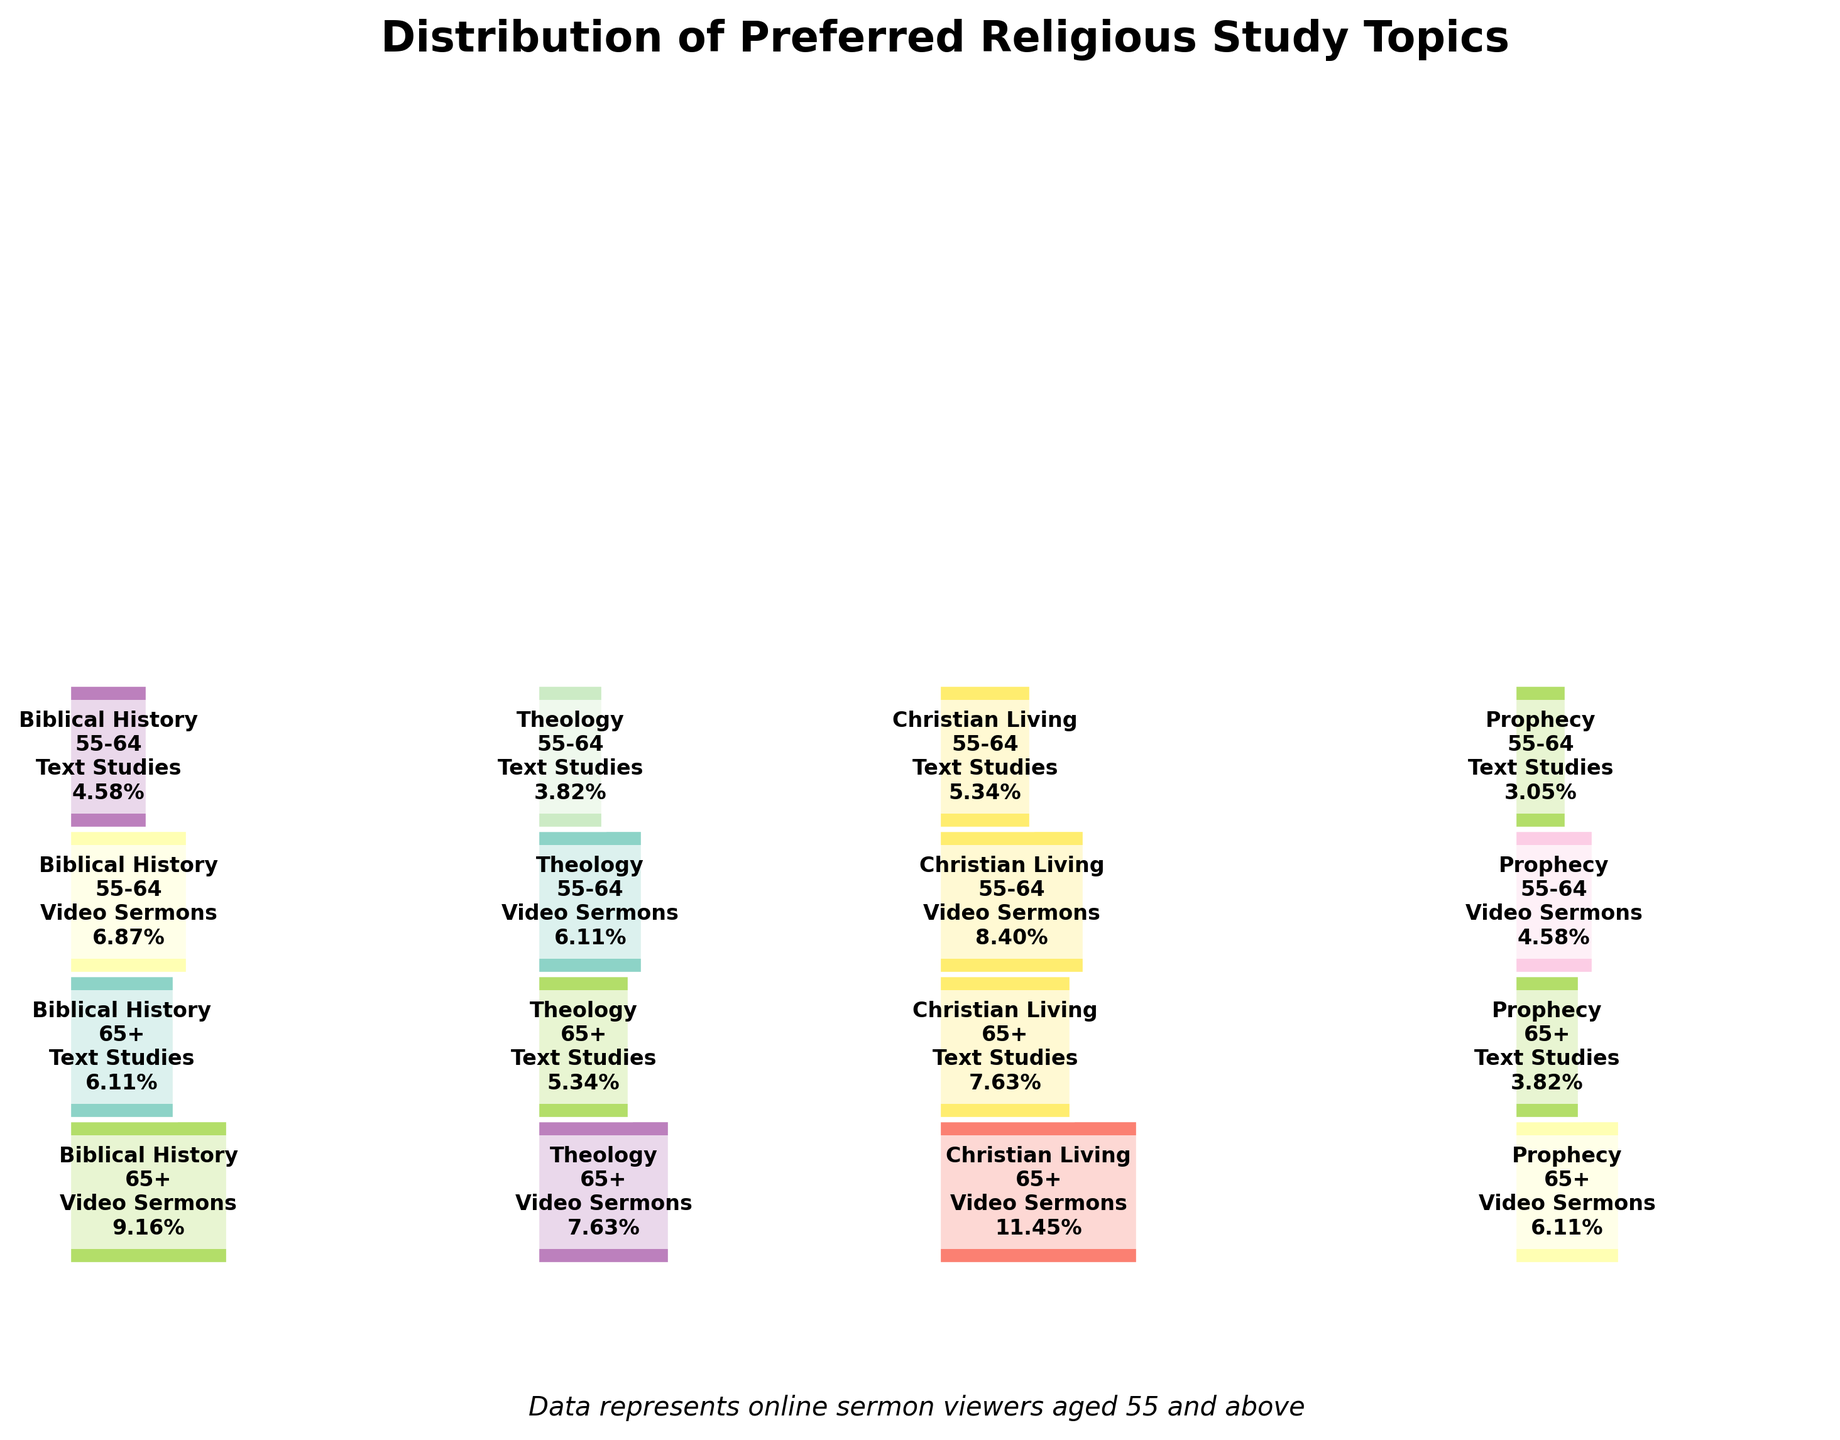What's the title of the plot? The title of the plot is usually displayed at the top of the figure. In this case, it is "Distribution of Preferred Religious Study Topics".
Answer: Distribution of Preferred Religious Study Topics Which age group tends to favor "Video Sermons" more for "Christian Living"? From the mosaic plot, you can compare the rectangles representing "Video Sermons" for both age groups under "Christian Living". The larger area indicates a higher count.
Answer: 65+ What proportion of people aged 55-64 prefer "Text Studies" for "Biblical History"? The figure shows proportions within each segment. Look for the segment labeled "Biblical History", "55-64", and "Text Studies". The proportion is given within this segment.
Answer: 2.89% How does the count of viewers aged 65+ who prefer "Video Sermons" for "Prophecy" compare to those aged 55-64 who prefer the same? Identify both the "Video Sermons" segments for the "Prophecy" topic across the two age groups and compare the sizes. Viewers aged 65+ have a larger segment.
Answer: Higher What is the smallest segment in the mosaic plot, and which category does it belong to? Look for the smallest rectangle in the plot. The smallest segment is labeled with its category and must be identified by checking the smallest proportion.
Answer: "Text Studies" for "Prophecy" among ages 55-64 What is the total number of people preferring "Text Studies" across all topics? Sum the counts from all segments labeled "Text Studies". The data shows counts for each segment, and you can add these together.
Answer: 420 What's the most preferred study method among the viewers aged 55-64 for "Christian Living"? Inspect the rectangle sizes for "Christian Living" in the 55-64 age group, comparing "Video Sermons" and "Text Studies". The larger rectangle represents the preferred method.
Answer: Video Sermons Compare the overall preference for "Biblical History" vs. "Theology" across all age groups and methods. Which one is more preferred? Sum the segments for "Biblical History" and "Theology" across both study methods and age groups. Compare the total sizes (proportions). "Biblical History" has a larger sum of proportions.
Answer: Biblical History Which topic has the largest proportion of people preferring "Video Sermons", and what is this proportion? Identify the largest proportion labeled "Video Sermons" across all topics and age groups.
Answer: "Christian Living", 16.95% How does the preference for “Text Studies” change from ages 55-64 to 65+ for "Theology"? Compare the heights of the rectangles for "Text Studies" in the "Theology" category between the two age groups.
Answer: It increases 